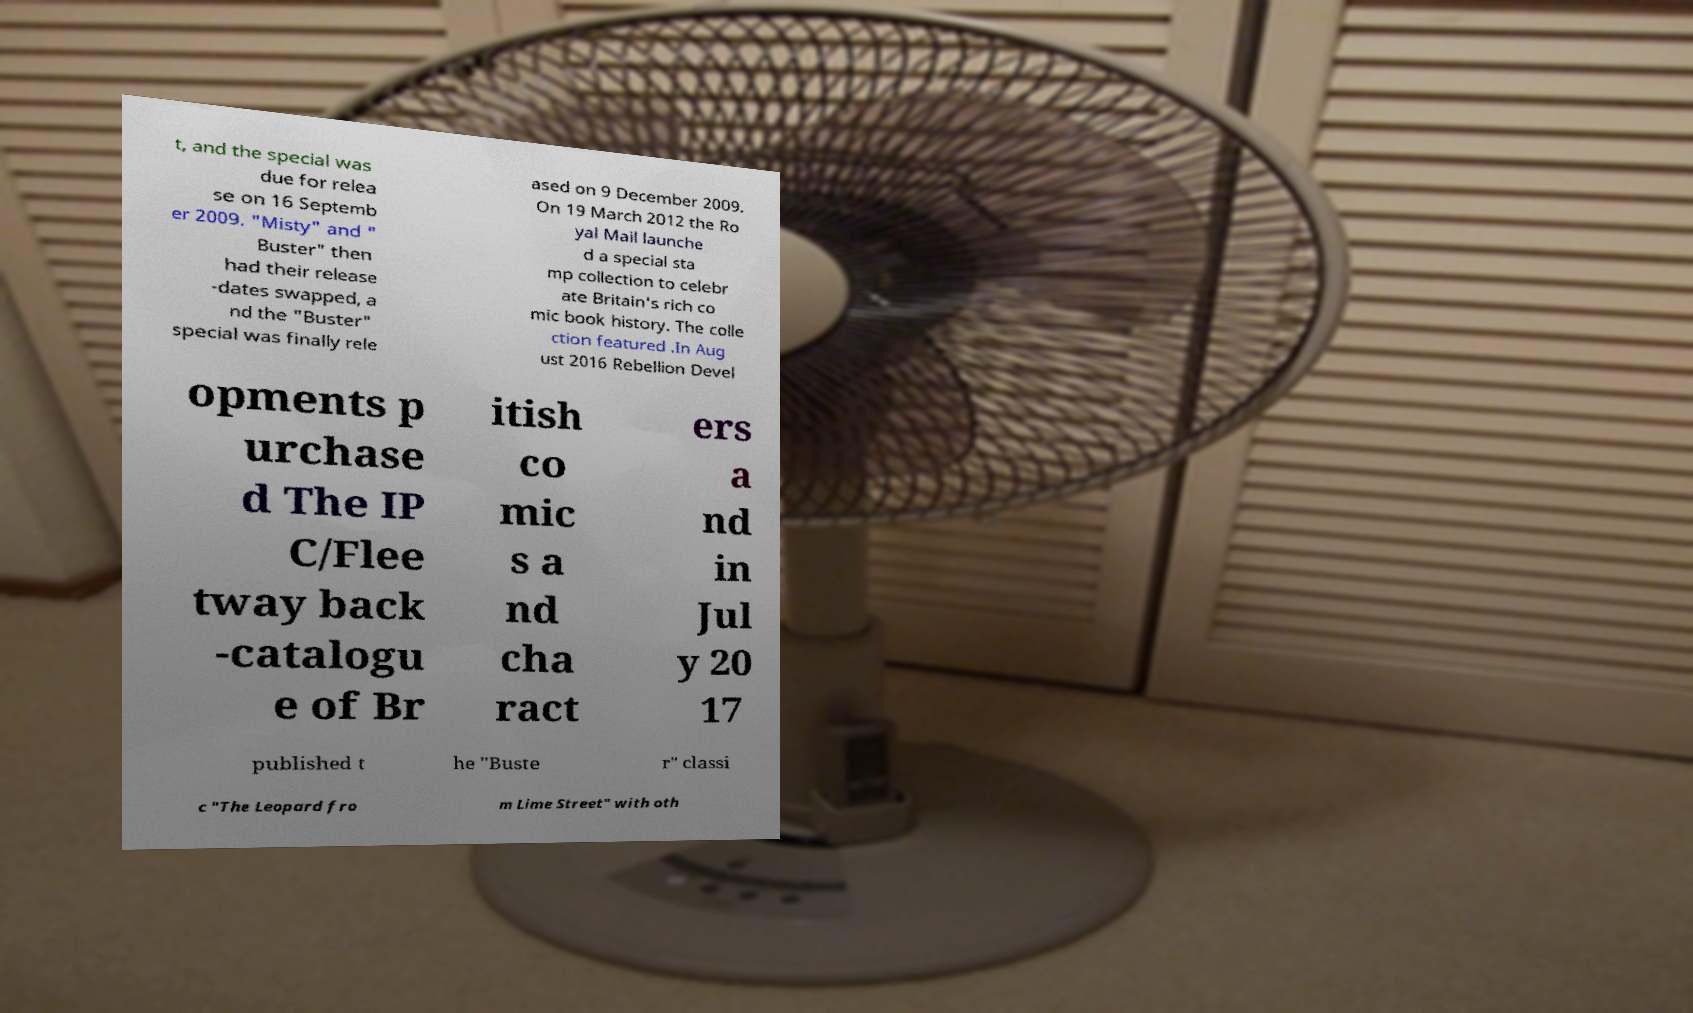For documentation purposes, I need the text within this image transcribed. Could you provide that? t, and the special was due for relea se on 16 Septemb er 2009. "Misty" and " Buster" then had their release -dates swapped, a nd the "Buster" special was finally rele ased on 9 December 2009. On 19 March 2012 the Ro yal Mail launche d a special sta mp collection to celebr ate Britain's rich co mic book history. The colle ction featured .In Aug ust 2016 Rebellion Devel opments p urchase d The IP C/Flee tway back -catalogu e of Br itish co mic s a nd cha ract ers a nd in Jul y 20 17 published t he "Buste r" classi c "The Leopard fro m Lime Street" with oth 